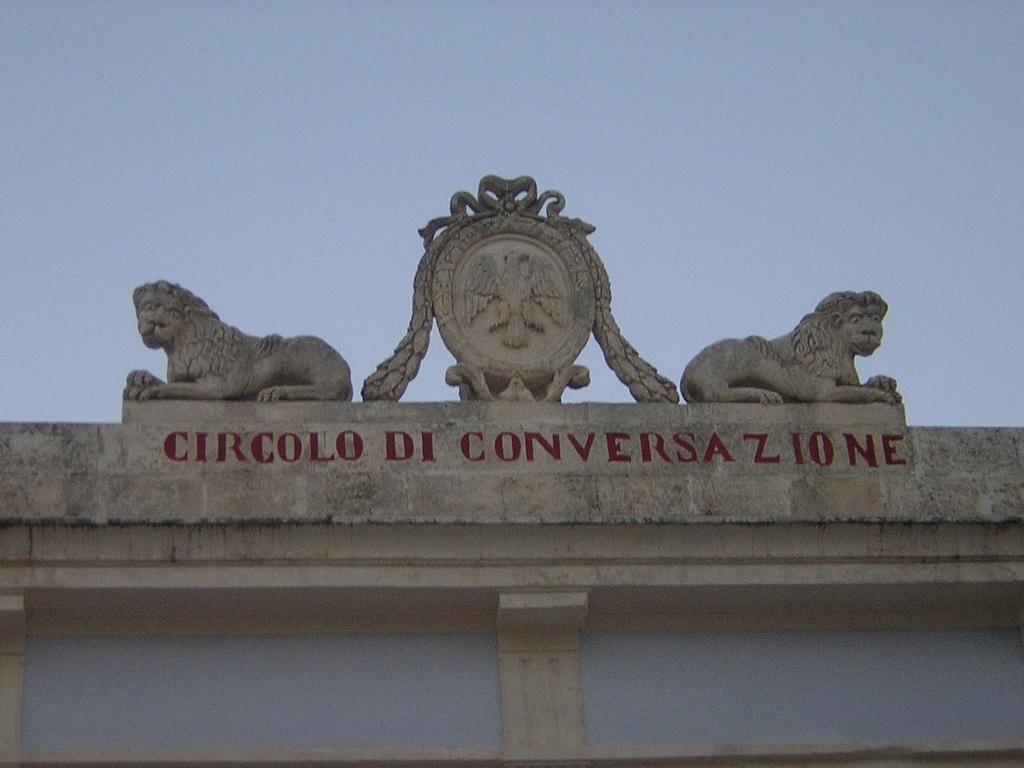What is present on the arch in the image? There are sculptures on the arch in the image. What can be seen in the background of the image? The sky is visible in the background of the image. What type of coil is being used to support the sculptures on the arch? There is no mention of a coil in the image, and the sculptures are supported by the structure of the arch itself. What lessons are being taught at the school in the image? There is no school present in the image; it features an arch with sculptures and a visible sky. 